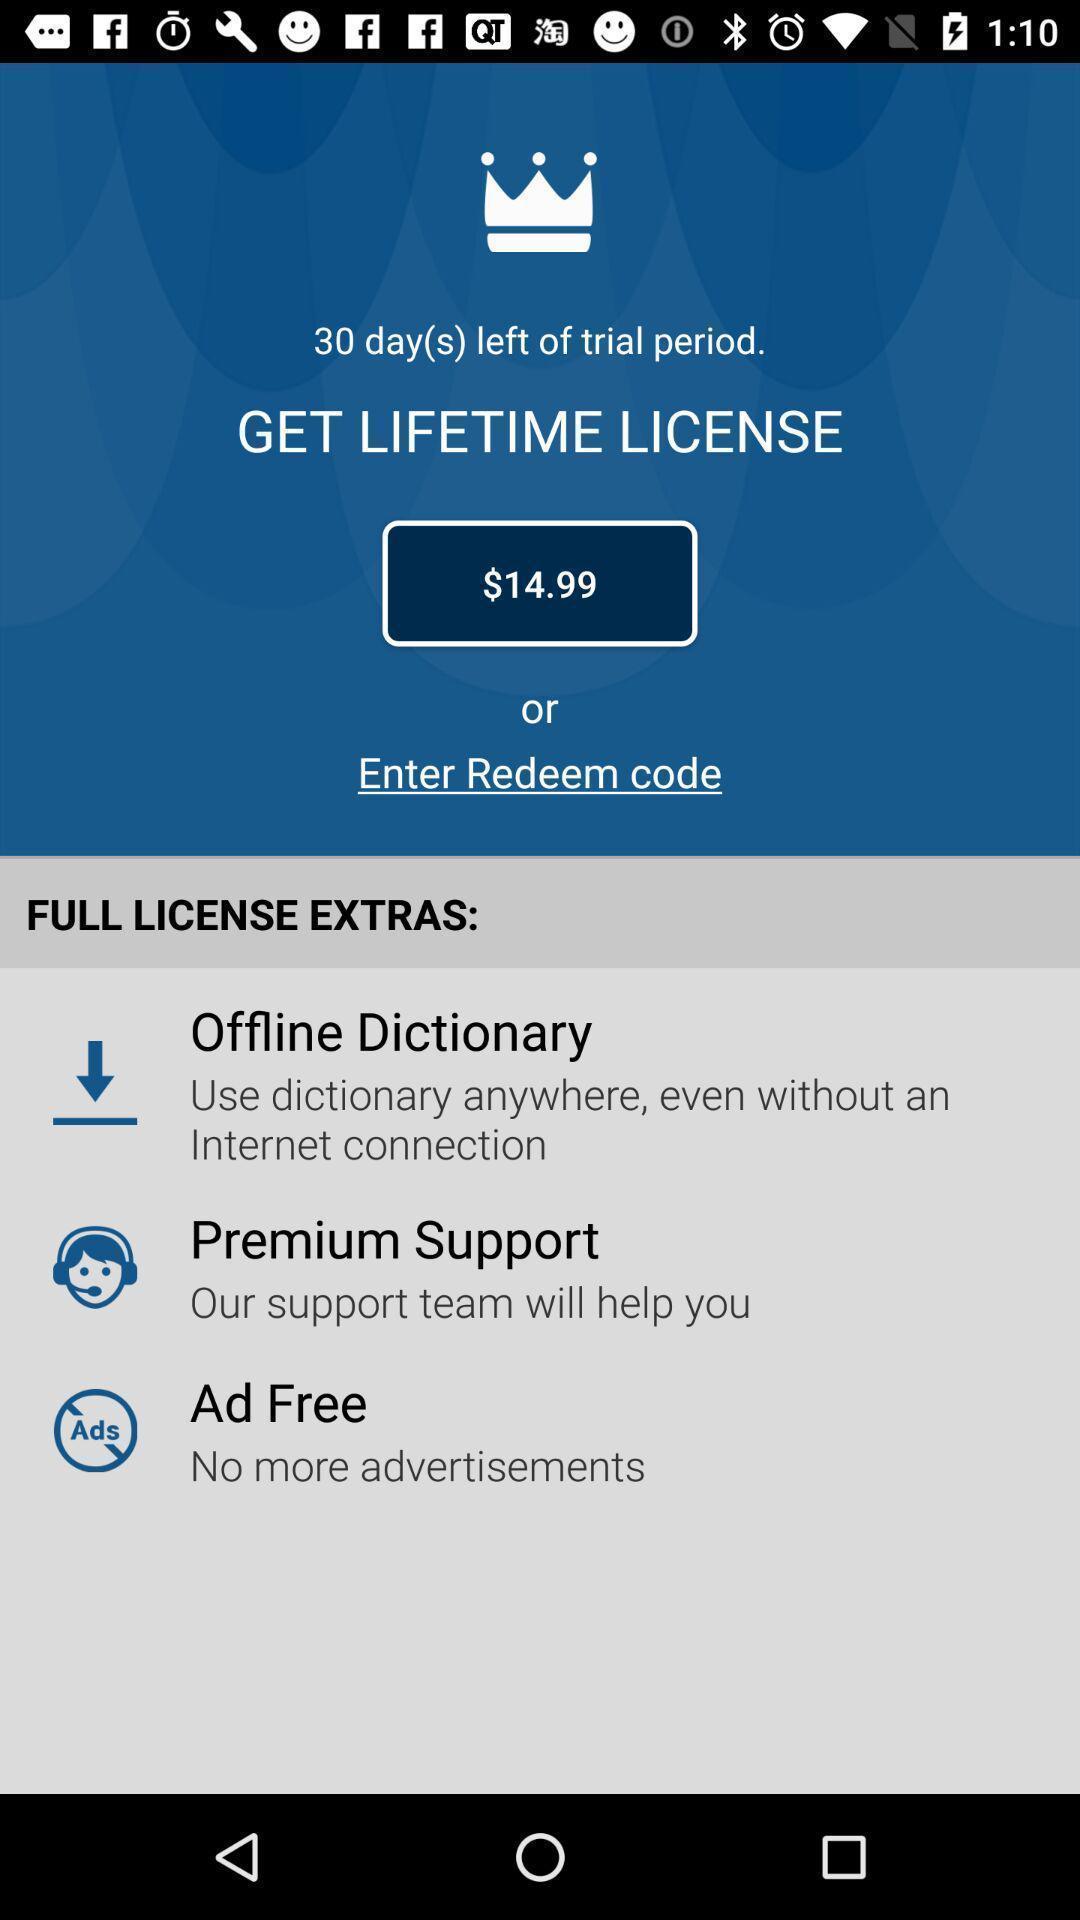Give me a narrative description of this picture. Screen displaying multiple license options and price details. 